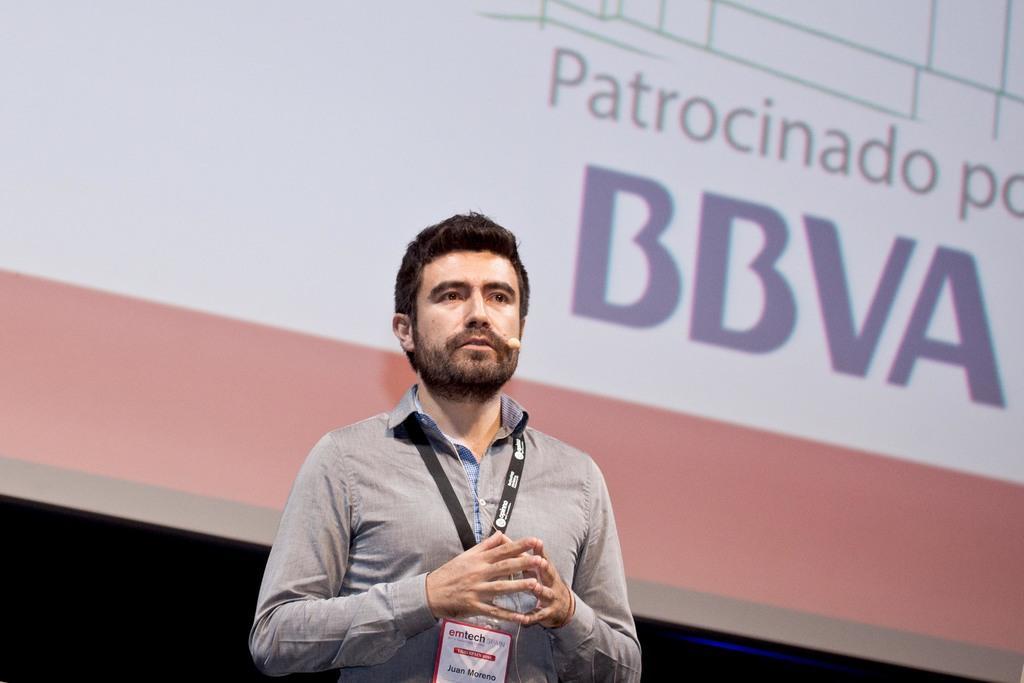Describe this image in one or two sentences. In the image we can see a man standing, wearing clothes, identity card and it looks like he is talking. Here we can see the microphone and the screen, we can even see the text on the screen. 